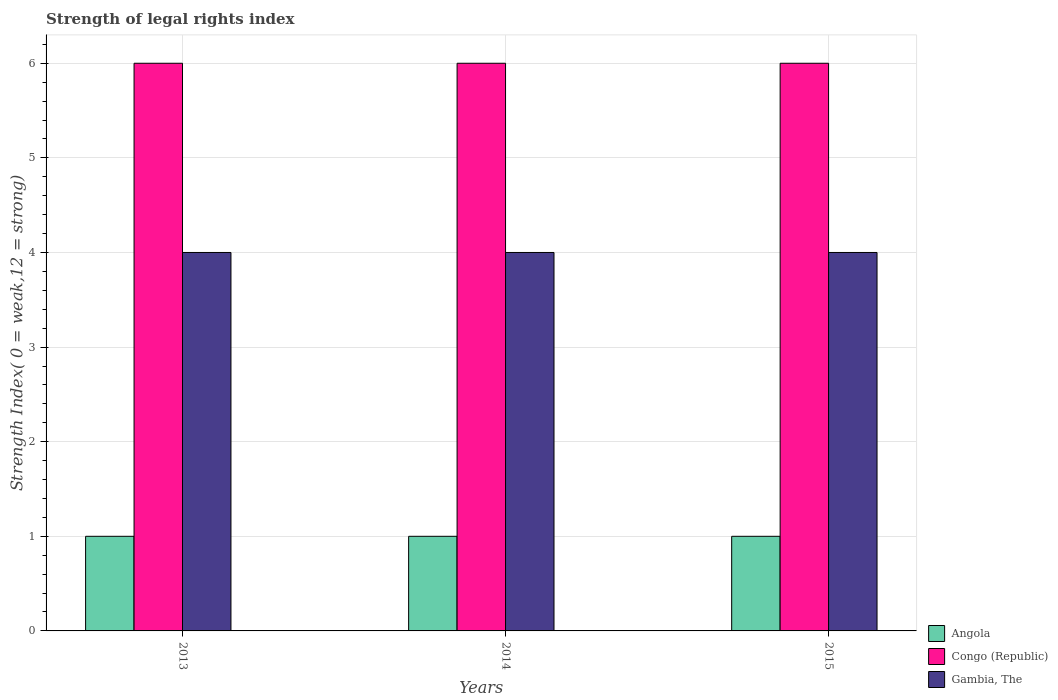How many different coloured bars are there?
Give a very brief answer. 3. What is the label of the 3rd group of bars from the left?
Provide a succinct answer. 2015. In how many cases, is the number of bars for a given year not equal to the number of legend labels?
Offer a very short reply. 0. What is the strength index in Angola in 2014?
Your response must be concise. 1. Across all years, what is the minimum strength index in Gambia, The?
Make the answer very short. 4. In which year was the strength index in Gambia, The maximum?
Your response must be concise. 2013. In which year was the strength index in Gambia, The minimum?
Give a very brief answer. 2013. What is the total strength index in Gambia, The in the graph?
Offer a very short reply. 12. What is the difference between the strength index in Congo (Republic) in 2014 and the strength index in Gambia, The in 2013?
Offer a very short reply. 2. What is the average strength index in Angola per year?
Your response must be concise. 1. In the year 2014, what is the difference between the strength index in Gambia, The and strength index in Congo (Republic)?
Make the answer very short. -2. In how many years, is the strength index in Gambia, The greater than 4.2?
Ensure brevity in your answer.  0. Is the strength index in Gambia, The in 2013 less than that in 2014?
Provide a succinct answer. No. Is the difference between the strength index in Gambia, The in 2014 and 2015 greater than the difference between the strength index in Congo (Republic) in 2014 and 2015?
Offer a very short reply. No. What is the difference between the highest and the second highest strength index in Congo (Republic)?
Offer a terse response. 0. What is the difference between the highest and the lowest strength index in Gambia, The?
Give a very brief answer. 0. Is the sum of the strength index in Angola in 2013 and 2015 greater than the maximum strength index in Congo (Republic) across all years?
Your answer should be compact. No. What does the 3rd bar from the left in 2013 represents?
Provide a short and direct response. Gambia, The. What does the 2nd bar from the right in 2013 represents?
Keep it short and to the point. Congo (Republic). Is it the case that in every year, the sum of the strength index in Gambia, The and strength index in Congo (Republic) is greater than the strength index in Angola?
Keep it short and to the point. Yes. How many bars are there?
Offer a terse response. 9. How many years are there in the graph?
Your answer should be compact. 3. What is the difference between two consecutive major ticks on the Y-axis?
Keep it short and to the point. 1. Does the graph contain grids?
Keep it short and to the point. Yes. Where does the legend appear in the graph?
Your answer should be very brief. Bottom right. How many legend labels are there?
Your response must be concise. 3. What is the title of the graph?
Keep it short and to the point. Strength of legal rights index. What is the label or title of the Y-axis?
Provide a short and direct response. Strength Index( 0 = weak,12 = strong). What is the Strength Index( 0 = weak,12 = strong) of Angola in 2014?
Keep it short and to the point. 1. What is the Strength Index( 0 = weak,12 = strong) in Congo (Republic) in 2014?
Your response must be concise. 6. What is the Strength Index( 0 = weak,12 = strong) in Gambia, The in 2014?
Your response must be concise. 4. What is the Strength Index( 0 = weak,12 = strong) of Angola in 2015?
Offer a very short reply. 1. What is the Strength Index( 0 = weak,12 = strong) in Congo (Republic) in 2015?
Ensure brevity in your answer.  6. What is the Strength Index( 0 = weak,12 = strong) in Gambia, The in 2015?
Offer a very short reply. 4. Across all years, what is the maximum Strength Index( 0 = weak,12 = strong) in Angola?
Your answer should be very brief. 1. Across all years, what is the maximum Strength Index( 0 = weak,12 = strong) of Congo (Republic)?
Offer a very short reply. 6. Across all years, what is the minimum Strength Index( 0 = weak,12 = strong) of Congo (Republic)?
Offer a terse response. 6. Across all years, what is the minimum Strength Index( 0 = weak,12 = strong) of Gambia, The?
Ensure brevity in your answer.  4. What is the total Strength Index( 0 = weak,12 = strong) in Angola in the graph?
Provide a short and direct response. 3. What is the total Strength Index( 0 = weak,12 = strong) in Gambia, The in the graph?
Offer a terse response. 12. What is the difference between the Strength Index( 0 = weak,12 = strong) in Congo (Republic) in 2013 and that in 2014?
Make the answer very short. 0. What is the difference between the Strength Index( 0 = weak,12 = strong) of Gambia, The in 2013 and that in 2014?
Ensure brevity in your answer.  0. What is the difference between the Strength Index( 0 = weak,12 = strong) of Congo (Republic) in 2013 and that in 2015?
Ensure brevity in your answer.  0. What is the difference between the Strength Index( 0 = weak,12 = strong) in Gambia, The in 2013 and that in 2015?
Provide a succinct answer. 0. What is the difference between the Strength Index( 0 = weak,12 = strong) in Angola in 2014 and that in 2015?
Give a very brief answer. 0. What is the difference between the Strength Index( 0 = weak,12 = strong) of Congo (Republic) in 2014 and that in 2015?
Your answer should be compact. 0. What is the difference between the Strength Index( 0 = weak,12 = strong) of Gambia, The in 2014 and that in 2015?
Your answer should be compact. 0. What is the difference between the Strength Index( 0 = weak,12 = strong) of Angola in 2013 and the Strength Index( 0 = weak,12 = strong) of Gambia, The in 2014?
Your response must be concise. -3. What is the difference between the Strength Index( 0 = weak,12 = strong) in Congo (Republic) in 2013 and the Strength Index( 0 = weak,12 = strong) in Gambia, The in 2014?
Keep it short and to the point. 2. What is the difference between the Strength Index( 0 = weak,12 = strong) in Congo (Republic) in 2013 and the Strength Index( 0 = weak,12 = strong) in Gambia, The in 2015?
Provide a short and direct response. 2. What is the difference between the Strength Index( 0 = weak,12 = strong) of Angola in 2014 and the Strength Index( 0 = weak,12 = strong) of Gambia, The in 2015?
Offer a very short reply. -3. What is the difference between the Strength Index( 0 = weak,12 = strong) of Congo (Republic) in 2014 and the Strength Index( 0 = weak,12 = strong) of Gambia, The in 2015?
Provide a short and direct response. 2. What is the average Strength Index( 0 = weak,12 = strong) of Angola per year?
Ensure brevity in your answer.  1. What is the average Strength Index( 0 = weak,12 = strong) of Congo (Republic) per year?
Give a very brief answer. 6. In the year 2013, what is the difference between the Strength Index( 0 = weak,12 = strong) in Angola and Strength Index( 0 = weak,12 = strong) in Gambia, The?
Your response must be concise. -3. In the year 2014, what is the difference between the Strength Index( 0 = weak,12 = strong) of Congo (Republic) and Strength Index( 0 = weak,12 = strong) of Gambia, The?
Offer a very short reply. 2. In the year 2015, what is the difference between the Strength Index( 0 = weak,12 = strong) in Angola and Strength Index( 0 = weak,12 = strong) in Congo (Republic)?
Ensure brevity in your answer.  -5. In the year 2015, what is the difference between the Strength Index( 0 = weak,12 = strong) in Angola and Strength Index( 0 = weak,12 = strong) in Gambia, The?
Give a very brief answer. -3. What is the ratio of the Strength Index( 0 = weak,12 = strong) in Congo (Republic) in 2013 to that in 2014?
Your answer should be very brief. 1. What is the ratio of the Strength Index( 0 = weak,12 = strong) in Congo (Republic) in 2013 to that in 2015?
Make the answer very short. 1. What is the ratio of the Strength Index( 0 = weak,12 = strong) of Gambia, The in 2014 to that in 2015?
Offer a terse response. 1. What is the difference between the highest and the second highest Strength Index( 0 = weak,12 = strong) in Angola?
Offer a terse response. 0. What is the difference between the highest and the second highest Strength Index( 0 = weak,12 = strong) of Congo (Republic)?
Provide a succinct answer. 0. What is the difference between the highest and the second highest Strength Index( 0 = weak,12 = strong) of Gambia, The?
Provide a succinct answer. 0. What is the difference between the highest and the lowest Strength Index( 0 = weak,12 = strong) of Gambia, The?
Your answer should be compact. 0. 